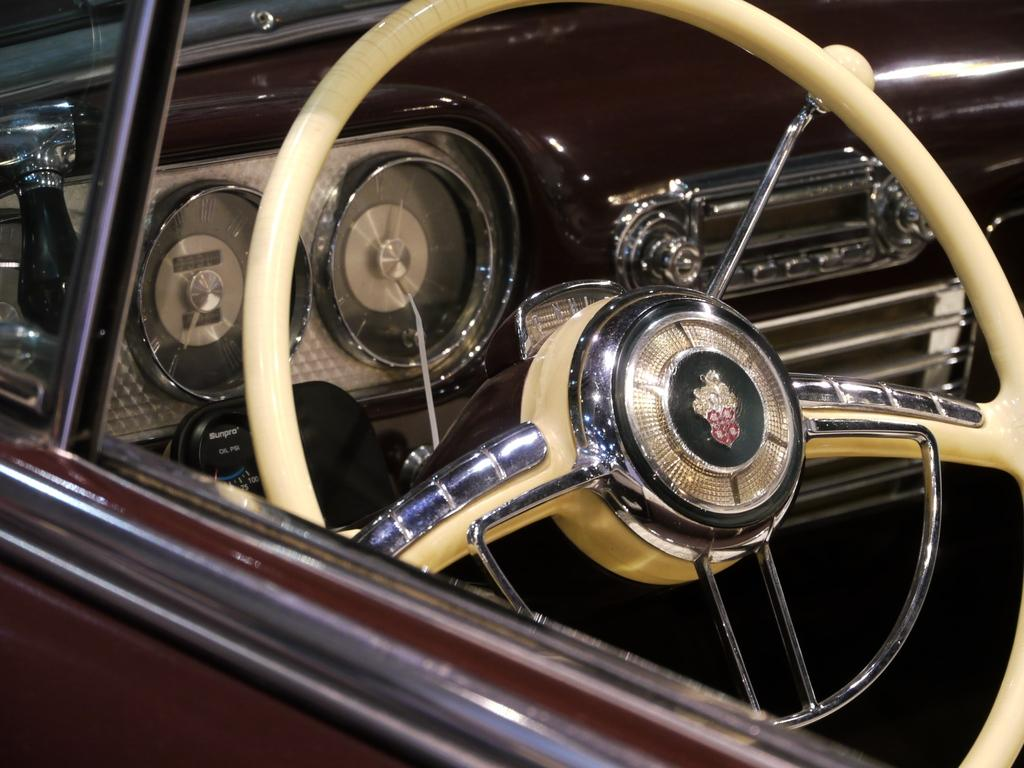What is the main object in the image? There is a car steering wheel in the image. Is there any branding or identification on the steering wheel? Yes, there is a logo is attached to the steering wheel. What type of vehicle is the steering wheel from? The image contains a car. What instrument might be used to measure the speed of the car? There are speedometers visible in the image. Can you tell if there is any entertainment system in the car? It is mentioned that there might be a music player in the car. What type of plantation can be seen in the background of the image? There is no plantation present in the image; it features a car steering wheel, logo, and speedometers. How does the farmer interact with the car in the image? There is no farmer or interaction with a car in the image. 